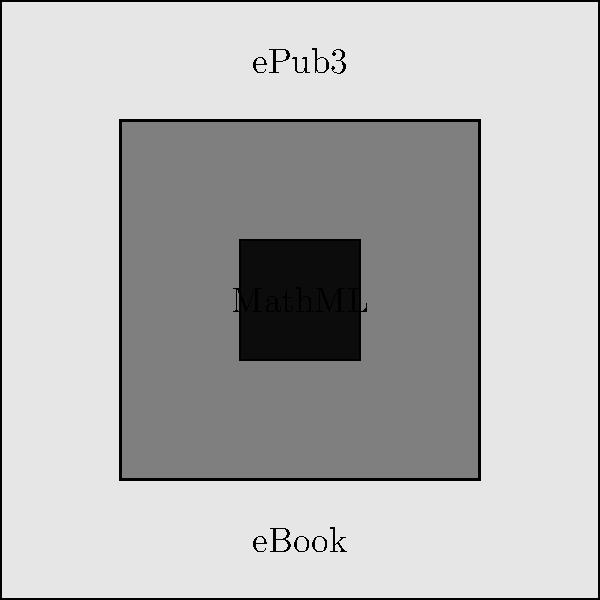Which MathML markup would be most appropriate for representing the following complex equation in an ePub3 eBook?

$$\frac{\partial^2 u}{\partial t^2} = c^2 \nabla^2 u + \frac{1}{\rho} \frac{\partial f}{\partial t}$$ To determine the most appropriate MathML markup for this complex equation in an ePub3 eBook, we need to consider the following steps:

1. Recognize that this is the wave equation with a forcing term, which requires precise representation.

2. Understand that ePub3 supports MathML for mathematical equations, ensuring accessibility and proper rendering across different devices.

3. Choose between Content MathML and Presentation MathML:
   - Content MathML focuses on the meaning of the mathematical expression.
   - Presentation MathML describes the visual layout of the equation.

4. For eBooks, Presentation MathML is generally preferred as it ensures consistent visual representation across different reading systems.

5. The equation contains partial derivatives, fractions, and special symbols (nabla), which need to be accurately represented.

6. The appropriate Presentation MathML markup would use tags such as:
   - <mfrac> for fractions
   - <msup> for superscripts (partial derivatives)
   - <mi> for variables
   - <mo> for operators
   - <mrow> for grouping elements

7. The nabla symbol would be represented using the Unicode character ∇ or the entity &nabla;.

8. The entire equation should be wrapped in <math> tags with appropriate namespace declarations.

Therefore, the most appropriate MathML markup would be Presentation MathML, carefully structured to represent the equation's layout while ensuring compatibility with ePub3 reading systems.
Answer: Presentation MathML 